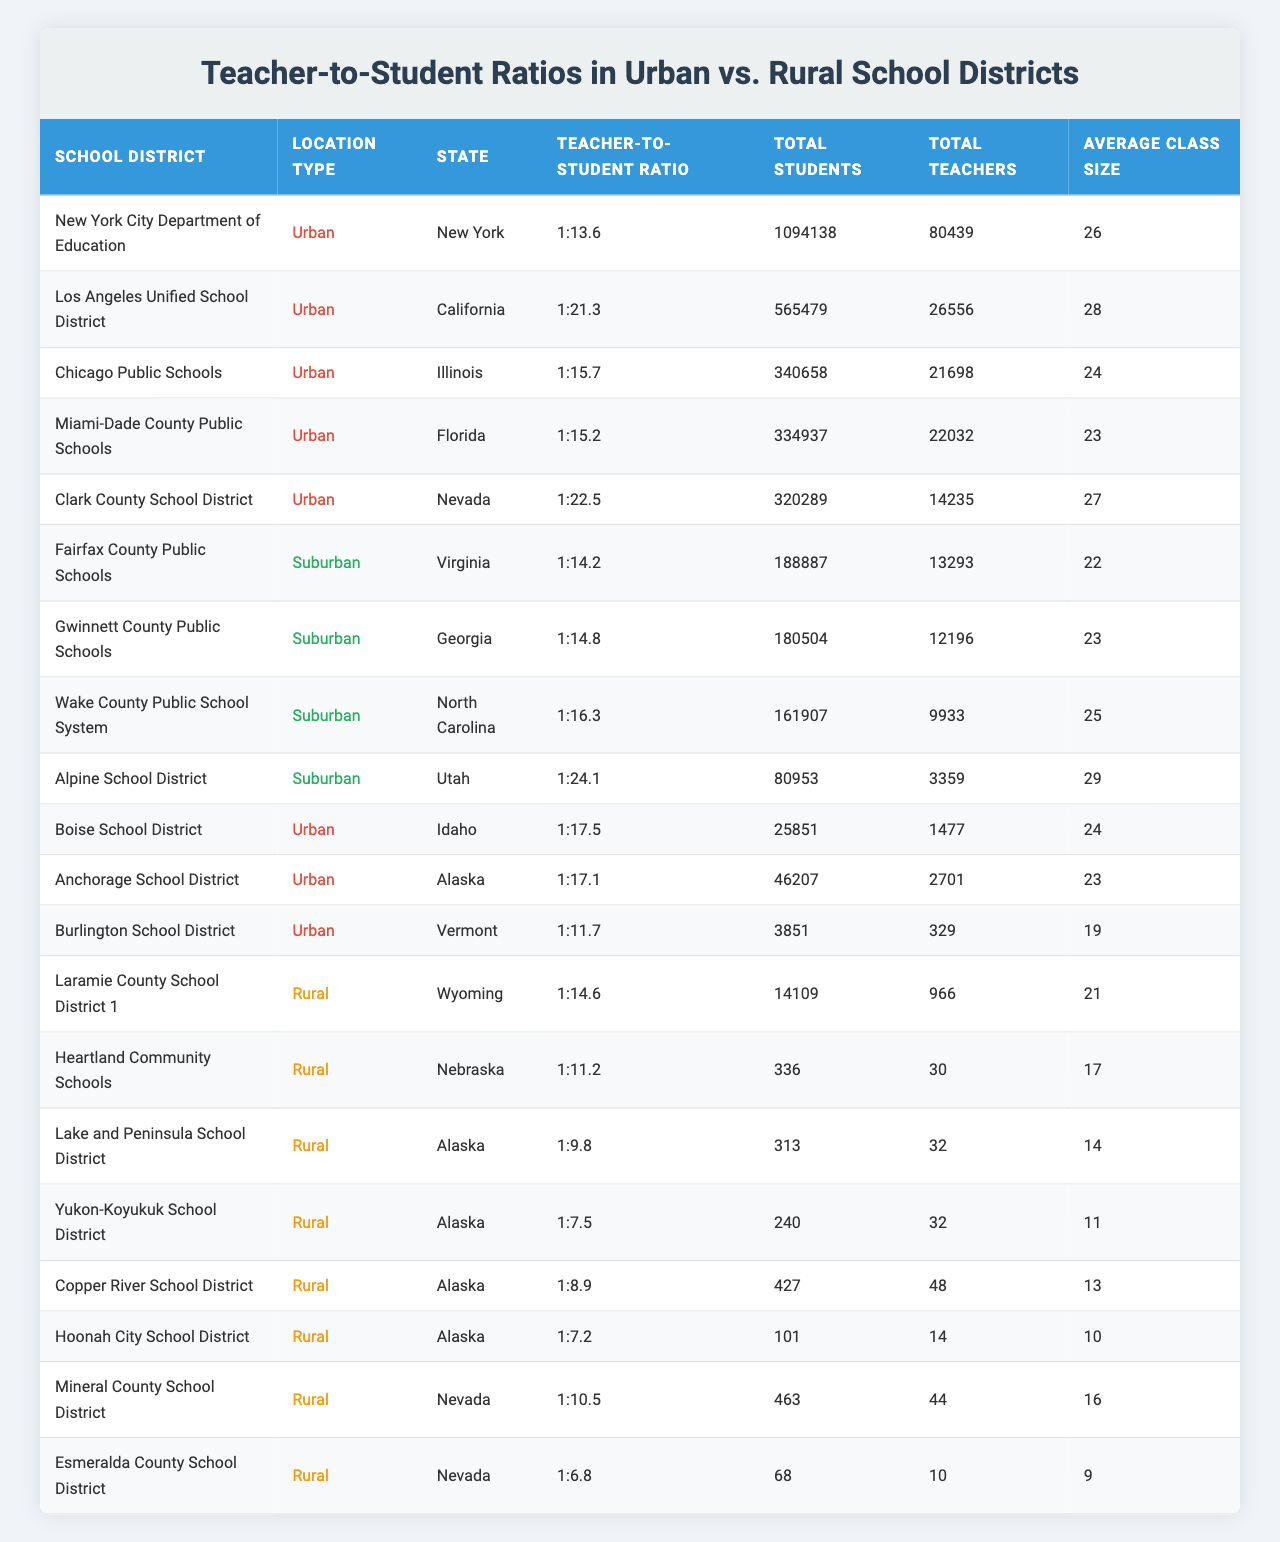What is the teacher-to-student ratio for New York City Department of Education? In the table, we can find the row for New York City Department of Education and see that its teacher-to-student ratio is 1:13.6.
Answer: 1:13.6 Which school district has the highest teacher-to-student ratio? By looking through the table, we see that the Yukon-Koyukuk School District has the highest ratio of 1:7.5, indicating fewer students per teacher.
Answer: Yukon-Koyukuk School District Is the average class size in the Los Angeles Unified School District larger than that in the Chicago Public Schools? The table shows that the average class size in Los Angeles is 28, whereas in Chicago it is 24. Since 28 is greater than 24, we can say yes.
Answer: Yes What is the total number of students in rural school districts? We need to sum the total students from all rural school districts listed: 14109 + 336 + 313 + 240 + 427 + 101 + 463 + 68 = 16957.
Answer: 16957 Are there more total teachers in urban school districts than in rural school districts combined? First, we need to count the total teachers in urban districts and rural districts respectively. For urban: 80439 + 26556 + 21698 + 22032 + 14235 + 1477 + 2701 + 329 = 107,807. For rural: 966 + 30 + 32 + 32 + 48 + 14 + 44 + 10 = 234. Since 107,807 is greater than 234, the answer is yes.
Answer: Yes What is the average teacher-to-student ratio for all urban school districts? The ratios for urban districts are: 1:13.6, 1:21.3, 1:15.7, 1:15.2, 1:22.5, 1:17.5, 1:17.1, and 1:11.7. Converting these ratios to a consistent format (i.e., decimals), we calculate their average: (13.6 + 21.3 + 15.7 + 15.2 + 22.5 + 17.5 + 17.1 + 11.7) / 8 = 17.2.
Answer: 1:17.2 Which type of school district has the smallest average class size? We can compare the average class sizes from the different location types. Urban schools have averages mostly around 24-28, rural shows smaller average sizes particularly with one as low as 10.7 for Hoonah City School District. The rural districts generally appear to have smaller averages.
Answer: Rural school districts How many teachers does the Lake and Peninsula School District have? In the table, we can see that the Lake and Peninsula School District has 32 total teachers listed.
Answer: 32 Which state has the urban school district with the fewest total students? From the table, we can see that Burlington School District in Vermont has the fewest total students, with only 3851.
Answer: Vermont What is the teacher-to-student ratio for rural school districts in Alaska? The teacher-to-student ratios for the rural districts in Alaska are 1:9.8 for Lake and Peninsula, 1:7.5 for Yukon-Koyukuk, 1:8.9 for Copper River, and 1:7.2 for Hoonah City. The average of these ratios is (9.8 + 7.5 + 8.9 + 7.2) / 4 = 8.35.
Answer: 1:8.35 